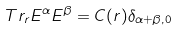Convert formula to latex. <formula><loc_0><loc_0><loc_500><loc_500>T r _ { r } E ^ { \alpha } E ^ { \beta } = C ( r ) \delta _ { \alpha + \beta , 0 }</formula> 